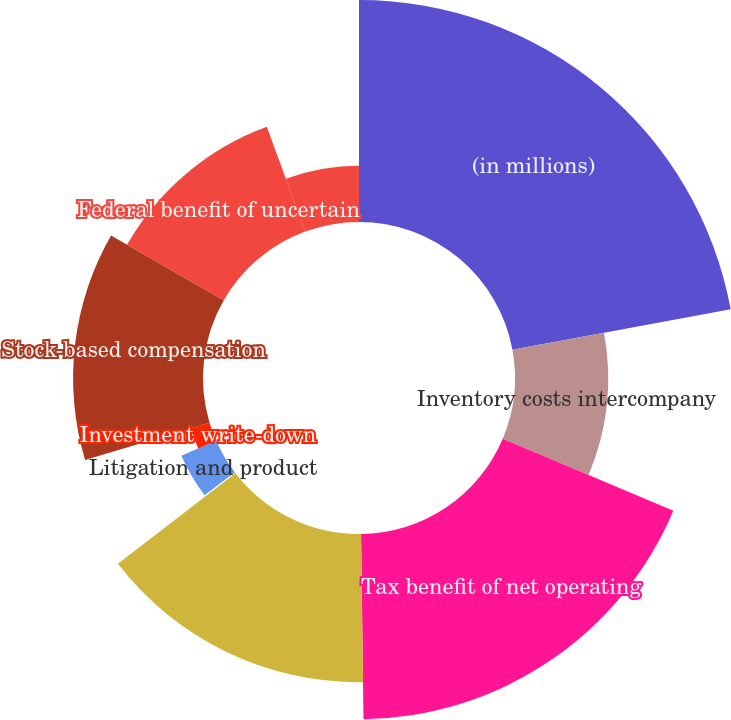<chart> <loc_0><loc_0><loc_500><loc_500><pie_chart><fcel>(in millions)<fcel>Inventory costs intercompany<fcel>Tax benefit of net operating<fcel>Reserves and accruals<fcel>Restructuring-related charges<fcel>Litigation and product<fcel>Investment write-down<fcel>Stock-based compensation<fcel>Federal benefit of uncertain<fcel>Other<nl><fcel>22.09%<fcel>9.27%<fcel>18.43%<fcel>14.76%<fcel>0.11%<fcel>3.77%<fcel>1.94%<fcel>12.93%<fcel>11.1%<fcel>5.6%<nl></chart> 